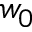<formula> <loc_0><loc_0><loc_500><loc_500>w _ { 0 }</formula> 